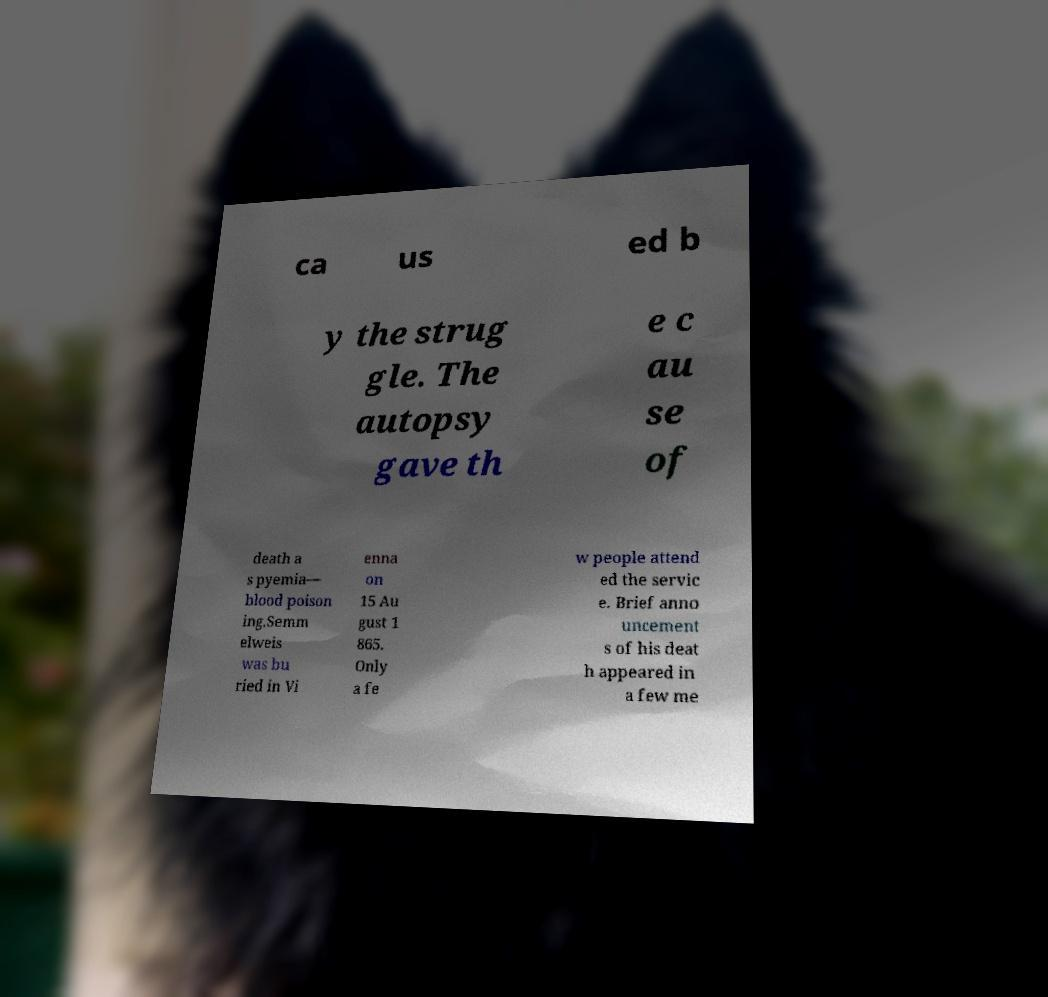I need the written content from this picture converted into text. Can you do that? ca us ed b y the strug gle. The autopsy gave th e c au se of death a s pyemia— blood poison ing.Semm elweis was bu ried in Vi enna on 15 Au gust 1 865. Only a fe w people attend ed the servic e. Brief anno uncement s of his deat h appeared in a few me 